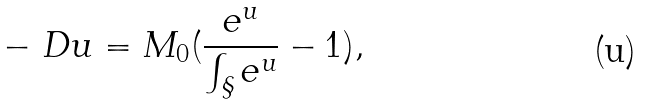<formula> <loc_0><loc_0><loc_500><loc_500>- \ D u = M _ { 0 } ( \frac { e ^ { u } } { \int _ { \S } e ^ { u } } - 1 ) ,</formula> 